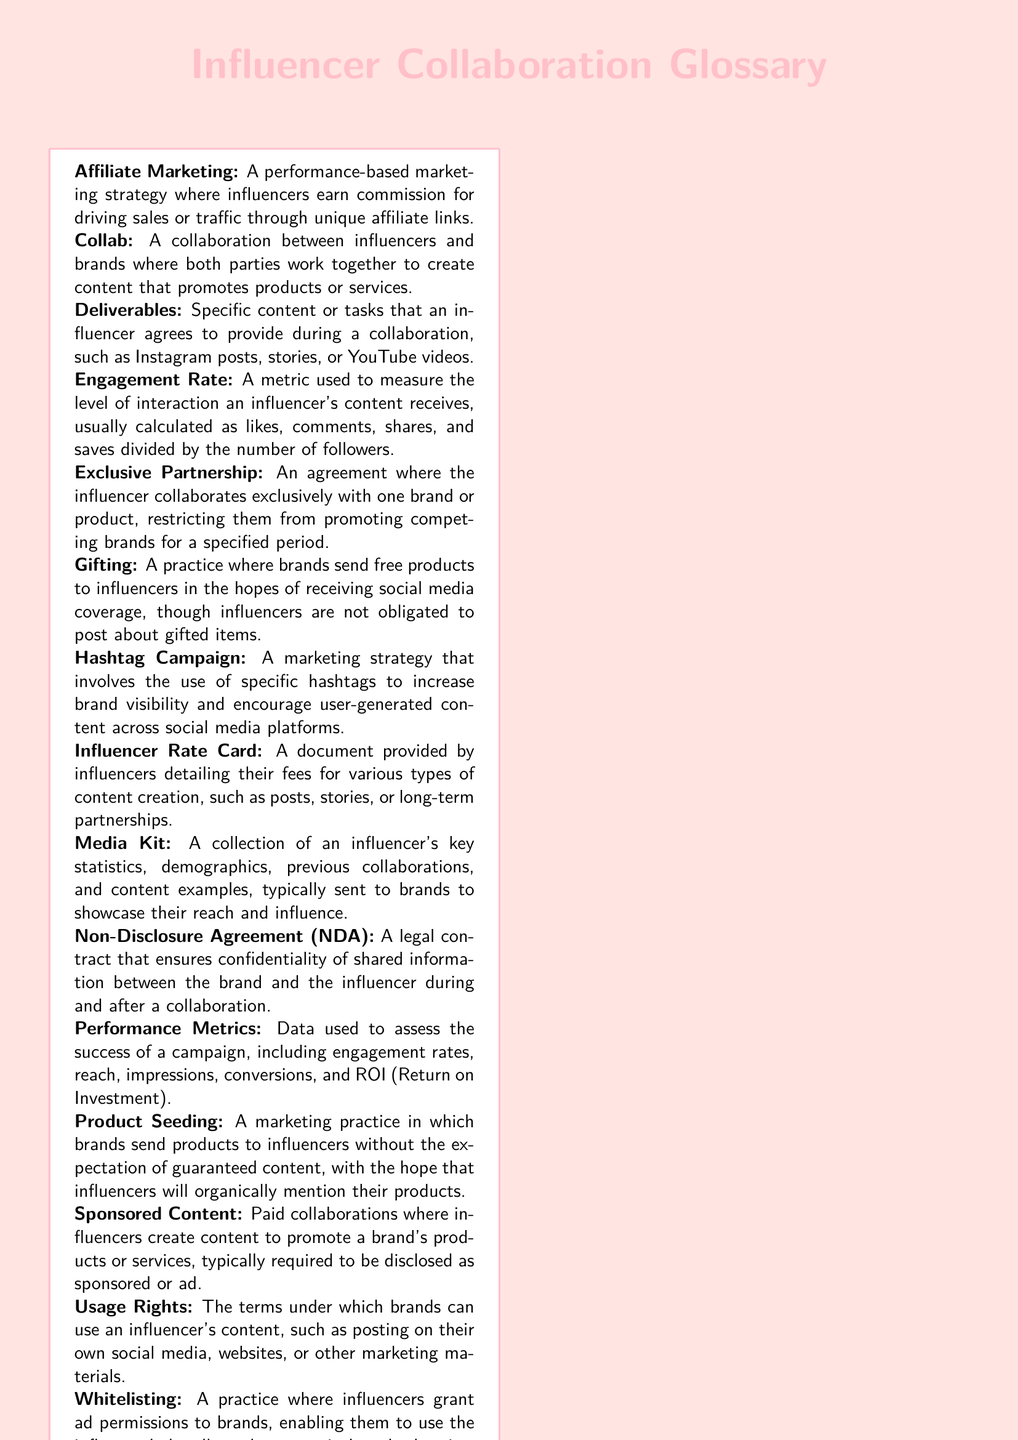What is the term for a marketing strategy where influencers earn commission for driving sales? This term is defined as a performance-based marketing strategy in the glossary.
Answer: Affiliate Marketing What does "Gifting" mean in the context of influencer collaborations? The glossary explains that this is a practice where brands send free products to influencers.
Answer: Sending free products What is an "Exclusive Partnership"? The glossary defines this as an agreement restricting the influencer from promoting competing brands.
Answer: Exclusive collaboration What document outlines an influencer's fees for various types of content? This document is specifically mentioned in the glossary, providing details on costs.
Answer: Influencer Rate Card What does "Whitelisting" refer to in influencer marketing? The glossary describes this as a practice where influencers grant ad permissions to brands.
Answer: Granting ad permissions What is the main purpose of a Media Kit? The glossary indicates that it showcases an influencer's reach and influence to brands.
Answer: Showcasing reach What kind of document ensures confidentiality during a collaboration? This specific type of document is mentioned in the glossary for legal purposes.
Answer: Non-Disclosure Agreement What type of content is required to be disclosed as sponsored? This type of content is defined clearly in the glossary regarding influencer collaborations.
Answer: Sponsored Content What does "Usage Rights" refer to? The glossary defines this as the terms under which brands can use an influencer's content.
Answer: Terms of content use 